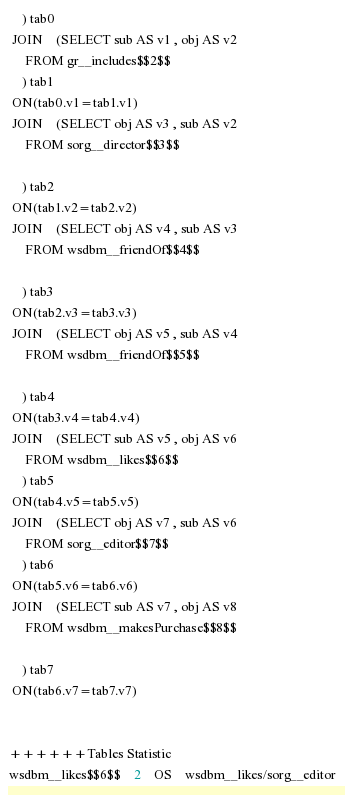<code> <loc_0><loc_0><loc_500><loc_500><_SQL_>	) tab0
 JOIN    (SELECT sub AS v1 , obj AS v2 
	 FROM gr__includes$$2$$
	) tab1
 ON(tab0.v1=tab1.v1)
 JOIN    (SELECT obj AS v3 , sub AS v2 
	 FROM sorg__director$$3$$
	
	) tab2
 ON(tab1.v2=tab2.v2)
 JOIN    (SELECT obj AS v4 , sub AS v3 
	 FROM wsdbm__friendOf$$4$$
	
	) tab3
 ON(tab2.v3=tab3.v3)
 JOIN    (SELECT obj AS v5 , sub AS v4 
	 FROM wsdbm__friendOf$$5$$
	
	) tab4
 ON(tab3.v4=tab4.v4)
 JOIN    (SELECT sub AS v5 , obj AS v6 
	 FROM wsdbm__likes$$6$$
	) tab5
 ON(tab4.v5=tab5.v5)
 JOIN    (SELECT obj AS v7 , sub AS v6 
	 FROM sorg__editor$$7$$
	) tab6
 ON(tab5.v6=tab6.v6)
 JOIN    (SELECT sub AS v7 , obj AS v8 
	 FROM wsdbm__makesPurchase$$8$$
	
	) tab7
 ON(tab6.v7=tab7.v7)


++++++Tables Statistic
wsdbm__likes$$6$$	2	OS	wsdbm__likes/sorg__editor</code> 